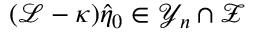<formula> <loc_0><loc_0><loc_500><loc_500>( \mathcal { L } - \kappa ) \hat { \eta } _ { 0 } \in \mathcal { Y } _ { n } \cap \mathcal { Z }</formula> 